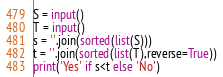<code> <loc_0><loc_0><loc_500><loc_500><_Python_>S = input()
T = input()
s = ''.join(sorted(list(S)))
t = ''.join(sorted(list(T),reverse=True))
print('Yes' if s<t else 'No')</code> 